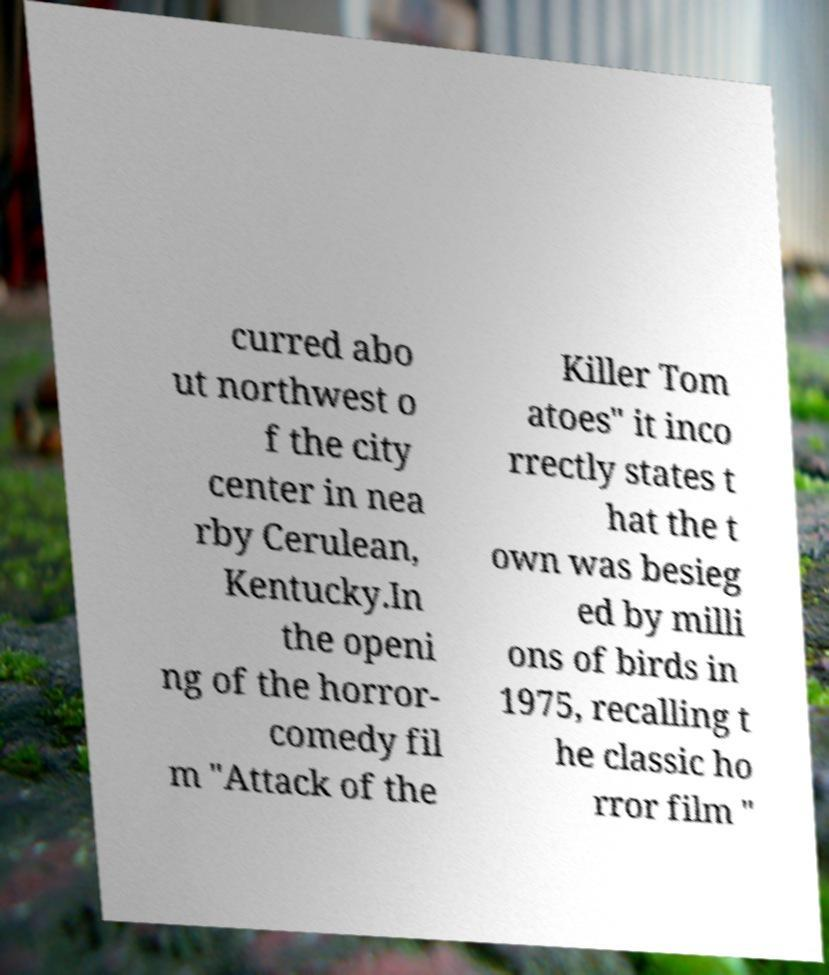I need the written content from this picture converted into text. Can you do that? curred abo ut northwest o f the city center in nea rby Cerulean, Kentucky.In the openi ng of the horror- comedy fil m "Attack of the Killer Tom atoes" it inco rrectly states t hat the t own was besieg ed by milli ons of birds in 1975, recalling t he classic ho rror film " 